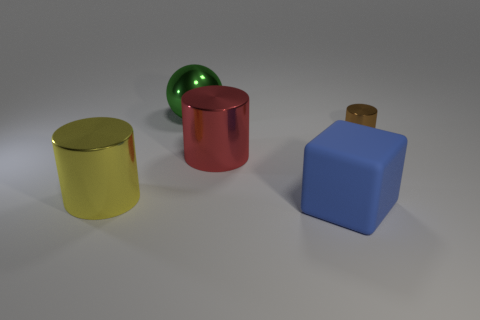Subtract all tiny brown shiny cylinders. How many cylinders are left? 2 Subtract all red cylinders. How many cylinders are left? 2 Add 1 green balls. How many objects exist? 6 Subtract all blue cylinders. Subtract all yellow blocks. How many cylinders are left? 3 Subtract all brown cylinders. Subtract all large gray metallic blocks. How many objects are left? 4 Add 4 large green objects. How many large green objects are left? 5 Add 4 big cyan metal cylinders. How many big cyan metal cylinders exist? 4 Subtract 0 cyan blocks. How many objects are left? 5 Subtract all cylinders. How many objects are left? 2 